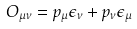<formula> <loc_0><loc_0><loc_500><loc_500>O _ { \mu \nu } = p _ { \mu } \epsilon _ { \nu } + p _ { \nu } \epsilon _ { \mu }</formula> 